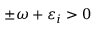<formula> <loc_0><loc_0><loc_500><loc_500>\pm \omega + \varepsilon _ { i } > 0</formula> 